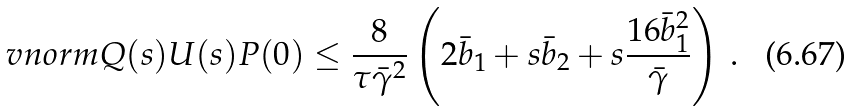Convert formula to latex. <formula><loc_0><loc_0><loc_500><loc_500>\ v n o r m { Q ( s ) U ( s ) P ( 0 ) } & \leq \frac { 8 } { \tau \bar { \gamma } ^ { 2 } } \left ( 2 \bar { b } _ { 1 } + s \bar { b } _ { 2 } + s \frac { 1 6 \bar { b } _ { 1 } ^ { 2 } } { \bar { \gamma } } \right ) \, .</formula> 